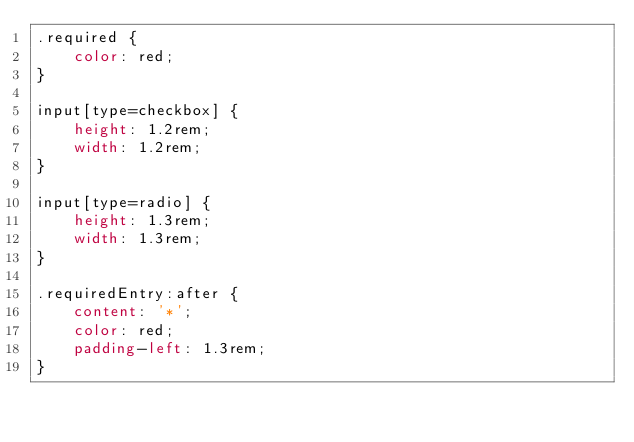<code> <loc_0><loc_0><loc_500><loc_500><_CSS_>.required {
	color: red;
}

input[type=checkbox] {
	height: 1.2rem;
	width: 1.2rem;
}

input[type=radio] {
	height: 1.3rem;
	width: 1.3rem;
}

.requiredEntry:after {
	content: '*';
	color: red;
	padding-left: 1.3rem;
}
</code> 